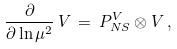Convert formula to latex. <formula><loc_0><loc_0><loc_500><loc_500>\frac { \partial } { \partial \ln \mu ^ { 2 } } \, V \, = \, P ^ { V } _ { N S } \otimes V \, ,</formula> 